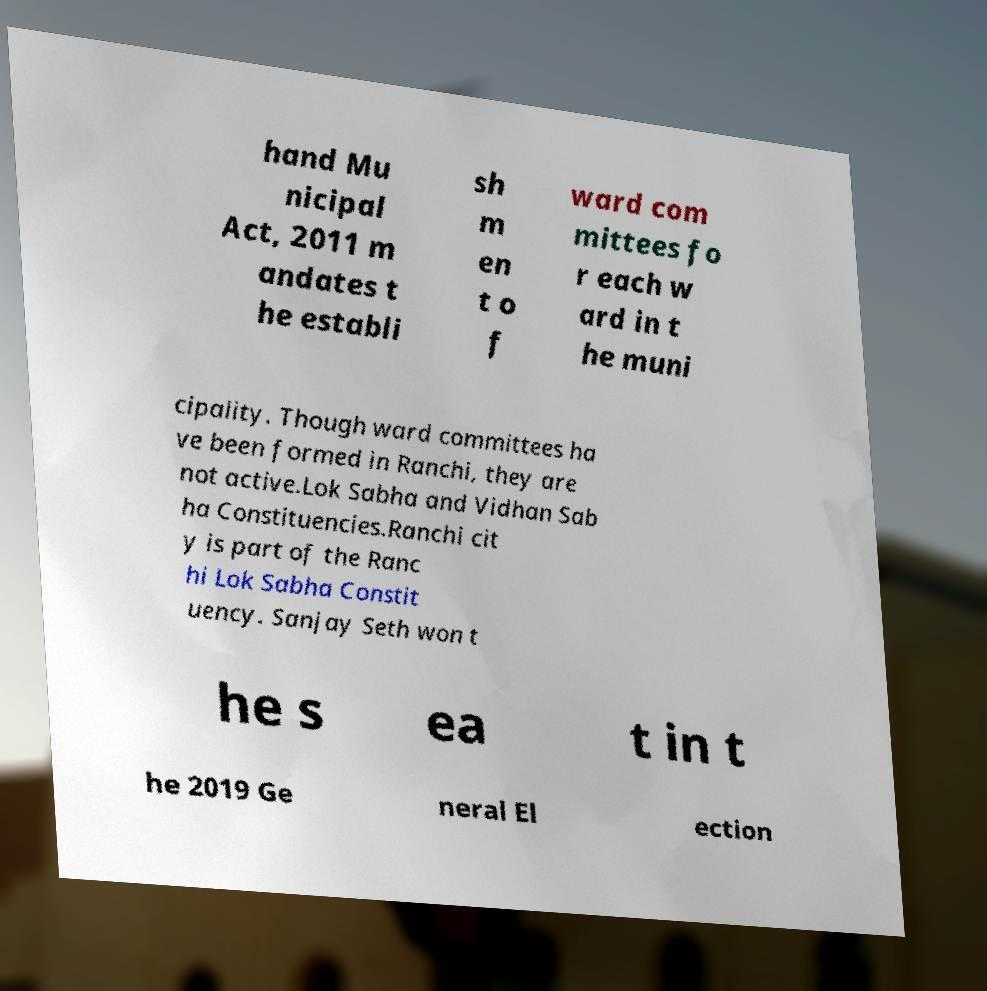Please read and relay the text visible in this image. What does it say? hand Mu nicipal Act, 2011 m andates t he establi sh m en t o f ward com mittees fo r each w ard in t he muni cipality. Though ward committees ha ve been formed in Ranchi, they are not active.Lok Sabha and Vidhan Sab ha Constituencies.Ranchi cit y is part of the Ranc hi Lok Sabha Constit uency. Sanjay Seth won t he s ea t in t he 2019 Ge neral El ection 